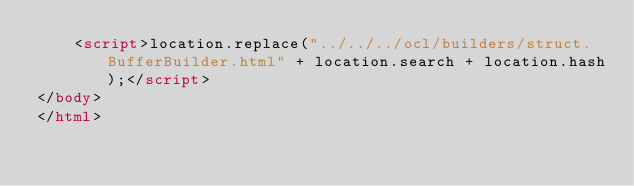<code> <loc_0><loc_0><loc_500><loc_500><_HTML_>    <script>location.replace("../../../ocl/builders/struct.BufferBuilder.html" + location.search + location.hash);</script>
</body>
</html></code> 